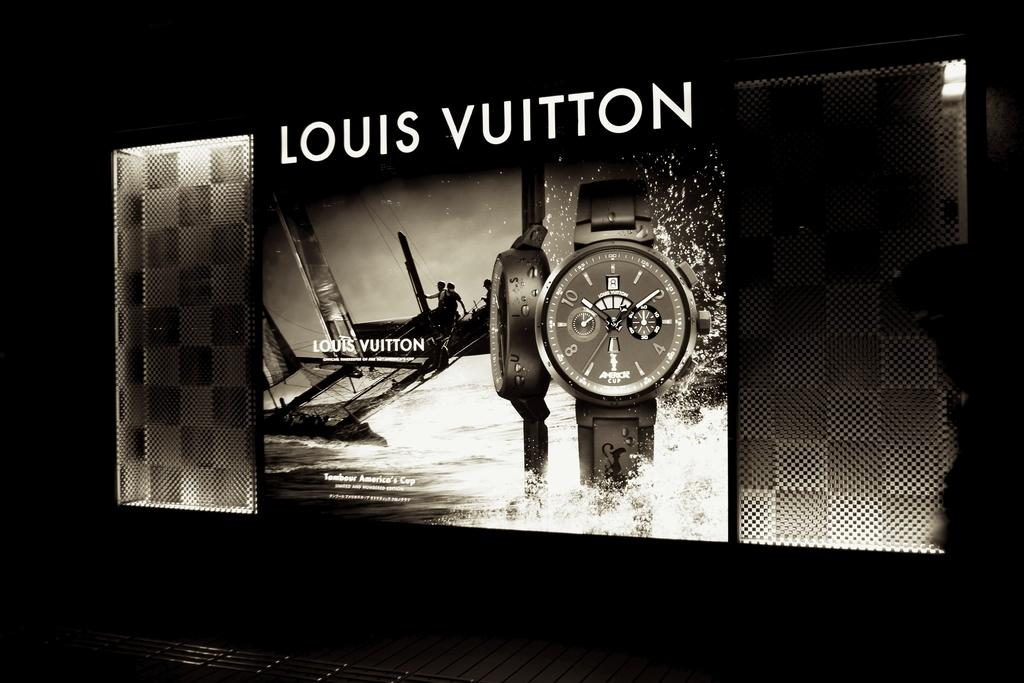<image>
Create a compact narrative representing the image presented. A black and white ad for a Louis Vuitton watch. 